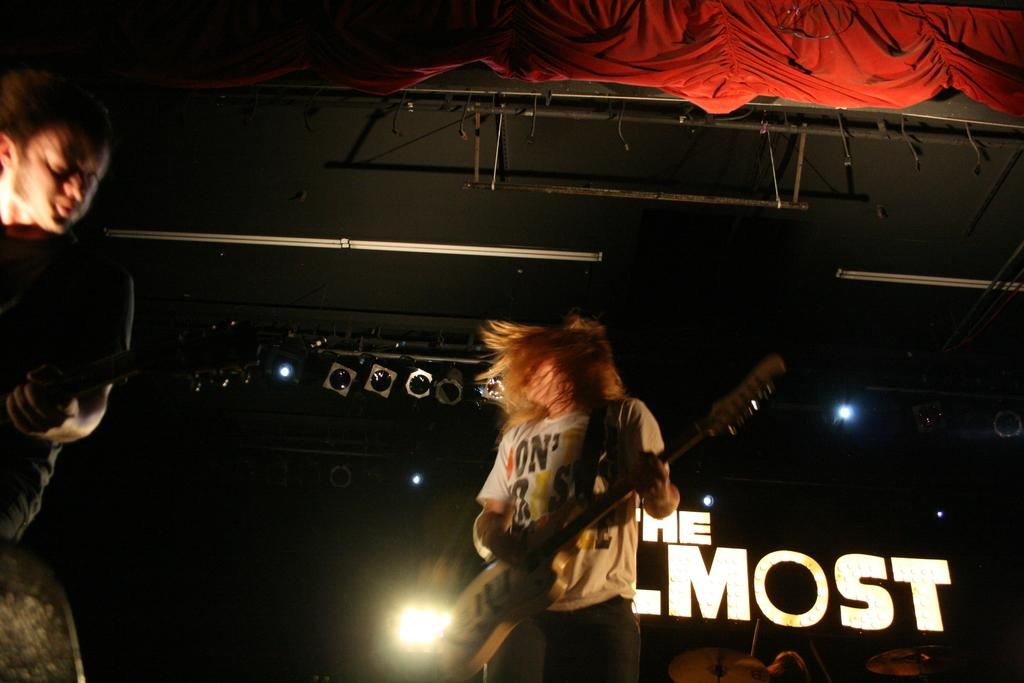How many people are in the image? There are two people in the image. What are the two people doing? The two people are standing and playing a guitar. What can be seen in the background of the image? There are lights in the background of the image. What is above the two people? There is a red curtain above the two people. How many goldfish are swimming in the guitar played by the two people? There are no goldfish present in the image, and they are not swimming in the guitar. 